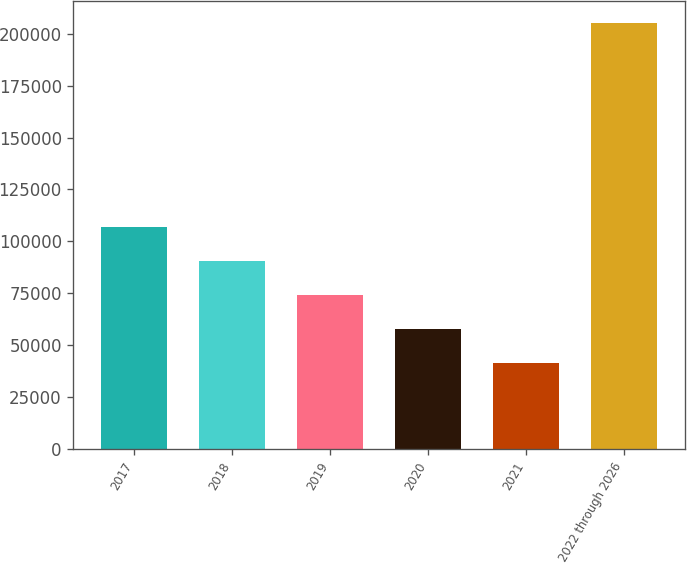Convert chart to OTSL. <chart><loc_0><loc_0><loc_500><loc_500><bar_chart><fcel>2017<fcel>2018<fcel>2019<fcel>2020<fcel>2021<fcel>2022 through 2026<nl><fcel>107028<fcel>90653<fcel>74278<fcel>57903<fcel>41528<fcel>205278<nl></chart> 